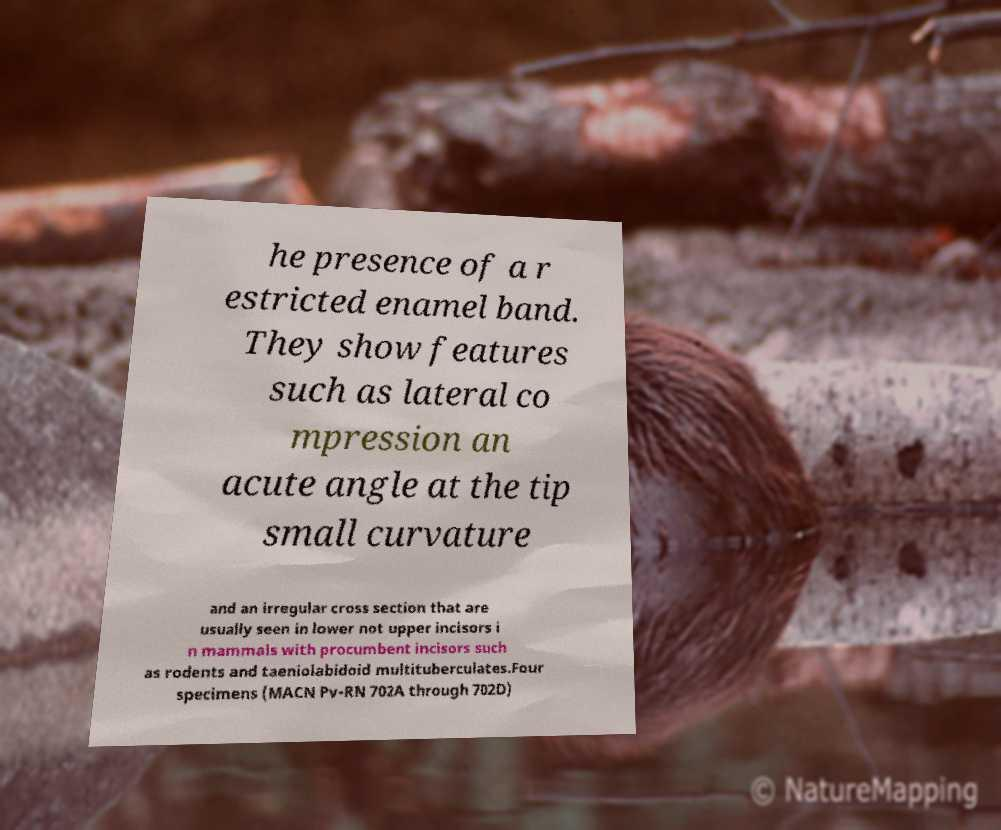Please identify and transcribe the text found in this image. he presence of a r estricted enamel band. They show features such as lateral co mpression an acute angle at the tip small curvature and an irregular cross section that are usually seen in lower not upper incisors i n mammals with procumbent incisors such as rodents and taeniolabidoid multituberculates.Four specimens (MACN Pv-RN 702A through 702D) 